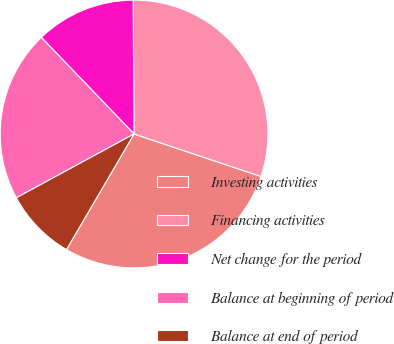Convert chart. <chart><loc_0><loc_0><loc_500><loc_500><pie_chart><fcel>Investing activities<fcel>Financing activities<fcel>Net change for the period<fcel>Balance at beginning of period<fcel>Balance at end of period<nl><fcel>28.28%<fcel>30.24%<fcel>12.07%<fcel>20.74%<fcel>8.67%<nl></chart> 